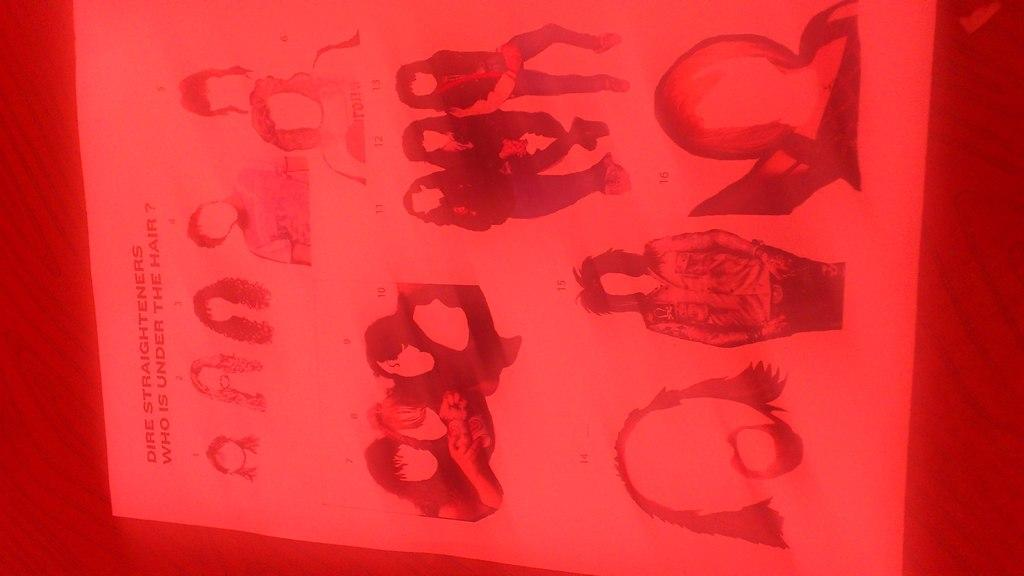What is present in the image? There is a poster in the image. What can be seen on the poster? The poster contains images of persons. What time is displayed on the clock in the image? There is no clock present in the image; it only contains a poster with images of persons. How many chickens are visible in the image? There are no chickens present in the image; it only contains a poster with images of persons. 